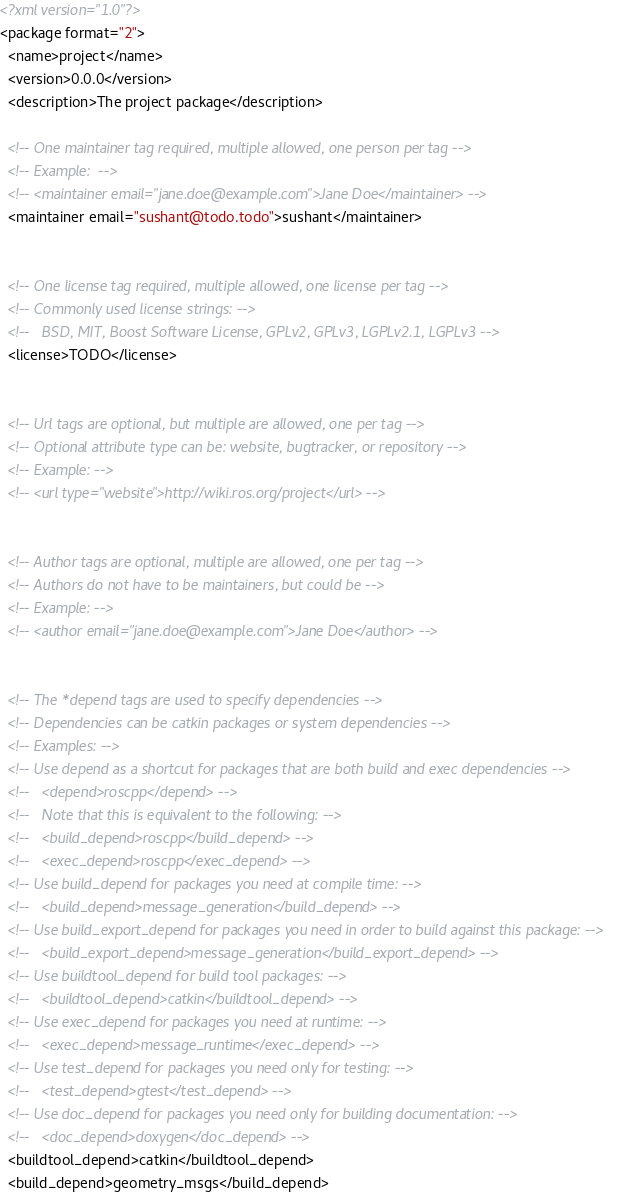Convert code to text. <code><loc_0><loc_0><loc_500><loc_500><_XML_><?xml version="1.0"?>
<package format="2">
  <name>project</name>
  <version>0.0.0</version>
  <description>The project package</description>

  <!-- One maintainer tag required, multiple allowed, one person per tag -->
  <!-- Example:  -->
  <!-- <maintainer email="jane.doe@example.com">Jane Doe</maintainer> -->
  <maintainer email="sushant@todo.todo">sushant</maintainer>


  <!-- One license tag required, multiple allowed, one license per tag -->
  <!-- Commonly used license strings: -->
  <!--   BSD, MIT, Boost Software License, GPLv2, GPLv3, LGPLv2.1, LGPLv3 -->
  <license>TODO</license>


  <!-- Url tags are optional, but multiple are allowed, one per tag -->
  <!-- Optional attribute type can be: website, bugtracker, or repository -->
  <!-- Example: -->
  <!-- <url type="website">http://wiki.ros.org/project</url> -->


  <!-- Author tags are optional, multiple are allowed, one per tag -->
  <!-- Authors do not have to be maintainers, but could be -->
  <!-- Example: -->
  <!-- <author email="jane.doe@example.com">Jane Doe</author> -->


  <!-- The *depend tags are used to specify dependencies -->
  <!-- Dependencies can be catkin packages or system dependencies -->
  <!-- Examples: -->
  <!-- Use depend as a shortcut for packages that are both build and exec dependencies -->
  <!--   <depend>roscpp</depend> -->
  <!--   Note that this is equivalent to the following: -->
  <!--   <build_depend>roscpp</build_depend> -->
  <!--   <exec_depend>roscpp</exec_depend> -->
  <!-- Use build_depend for packages you need at compile time: -->
  <!--   <build_depend>message_generation</build_depend> -->
  <!-- Use build_export_depend for packages you need in order to build against this package: -->
  <!--   <build_export_depend>message_generation</build_export_depend> -->
  <!-- Use buildtool_depend for build tool packages: -->
  <!--   <buildtool_depend>catkin</buildtool_depend> -->
  <!-- Use exec_depend for packages you need at runtime: -->
  <!--   <exec_depend>message_runtime</exec_depend> -->
  <!-- Use test_depend for packages you need only for testing: -->
  <!--   <test_depend>gtest</test_depend> -->
  <!-- Use doc_depend for packages you need only for building documentation: -->
  <!--   <doc_depend>doxygen</doc_depend> -->
  <buildtool_depend>catkin</buildtool_depend>
  <build_depend>geometry_msgs</build_depend></code> 